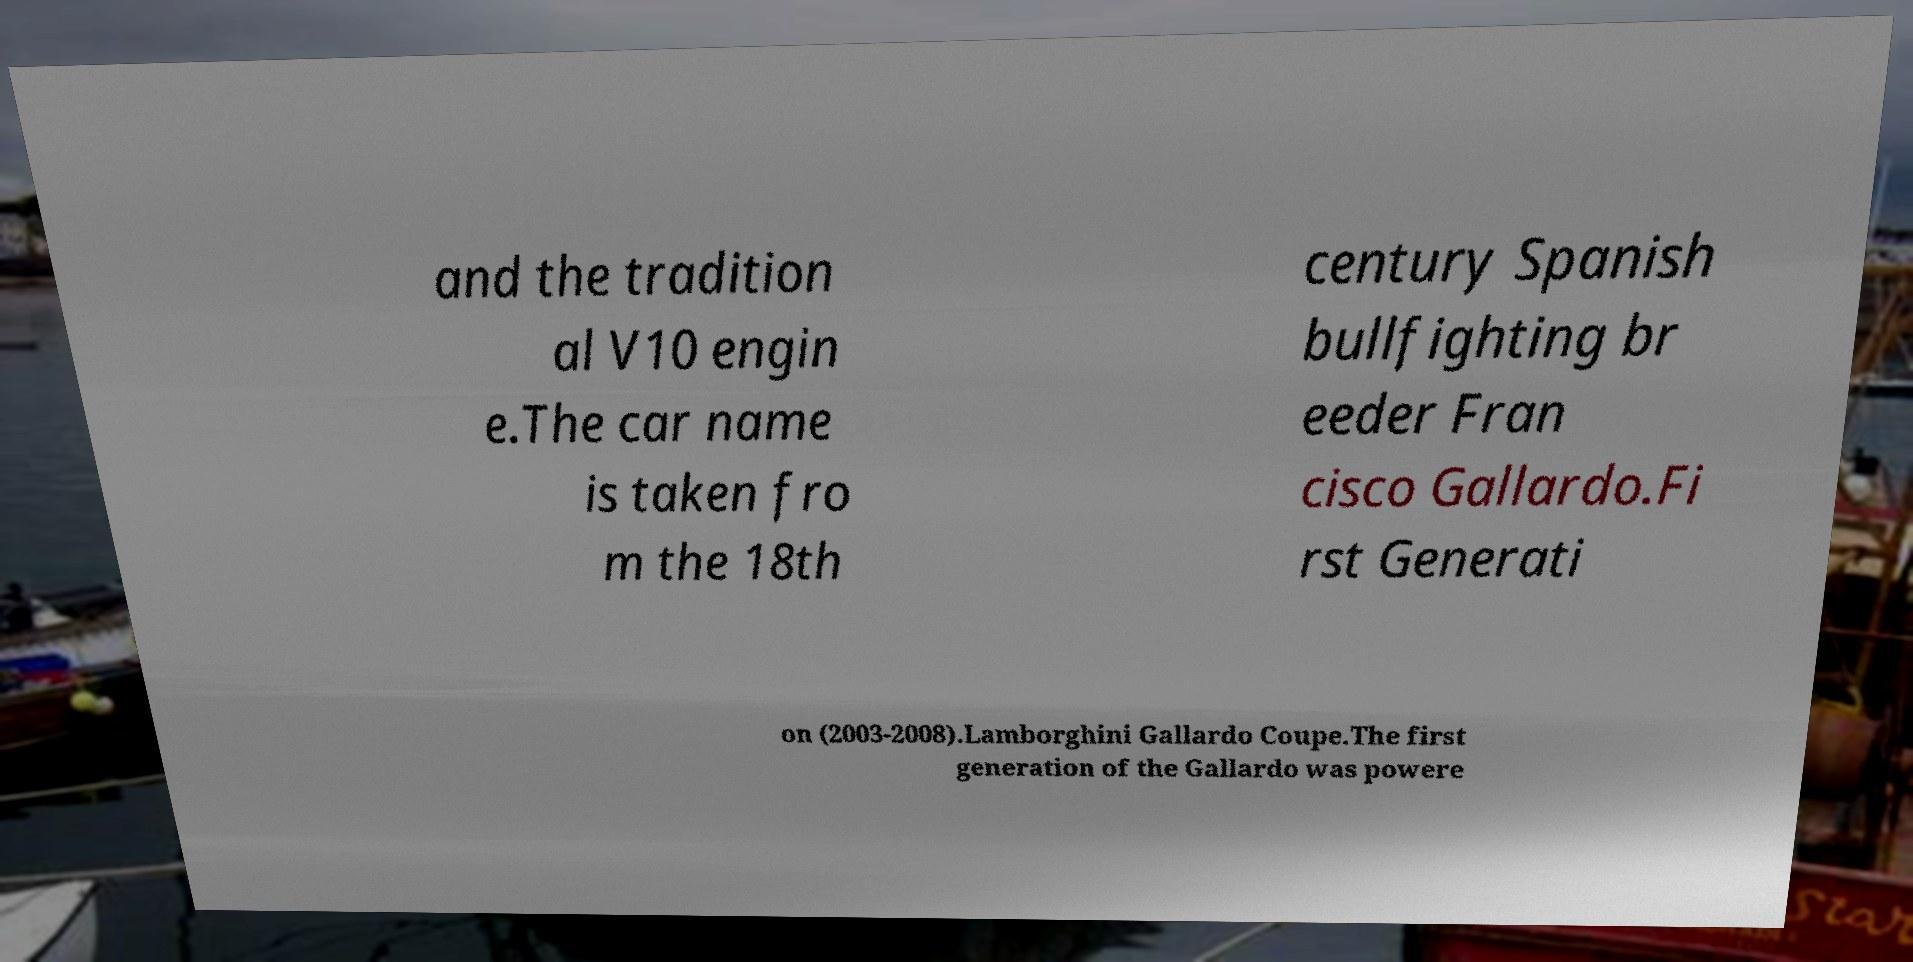There's text embedded in this image that I need extracted. Can you transcribe it verbatim? and the tradition al V10 engin e.The car name is taken fro m the 18th century Spanish bullfighting br eeder Fran cisco Gallardo.Fi rst Generati on (2003-2008).Lamborghini Gallardo Coupe.The first generation of the Gallardo was powere 